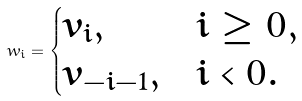<formula> <loc_0><loc_0><loc_500><loc_500>w _ { i } = \begin{cases} v _ { i } , & i \geq 0 , \\ v _ { - i - 1 } , & i < 0 . \end{cases}</formula> 